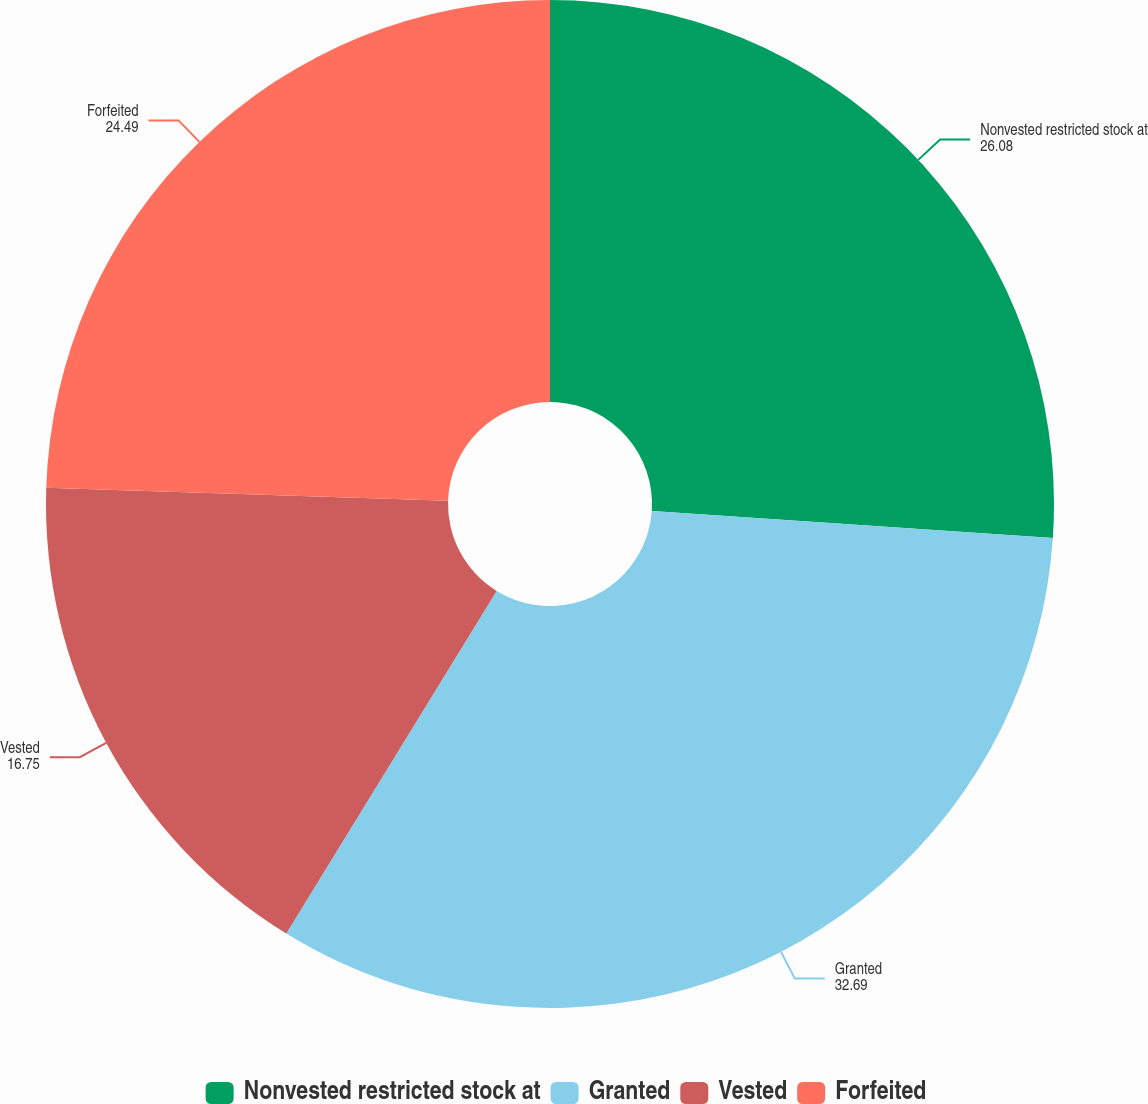<chart> <loc_0><loc_0><loc_500><loc_500><pie_chart><fcel>Nonvested restricted stock at<fcel>Granted<fcel>Vested<fcel>Forfeited<nl><fcel>26.08%<fcel>32.69%<fcel>16.75%<fcel>24.49%<nl></chart> 